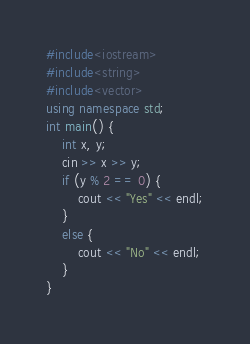Convert code to text. <code><loc_0><loc_0><loc_500><loc_500><_C++_>#include<iostream>
#include<string>
#include<vector>
using namespace std;
int main() {
    int x, y;
    cin >> x >> y;
    if (y % 2 == 0) {
        cout << "Yes" << endl;
    }
    else {
        cout << "No" << endl;
    }
}</code> 